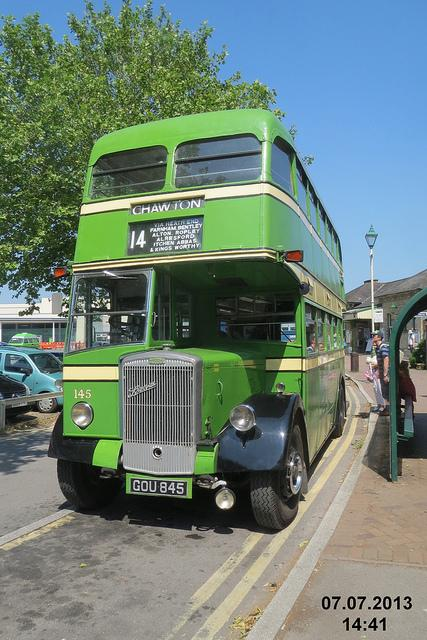In which country does this bus travel? Please explain your reasoning. great britain. The display on the front of the bus says chawton. chawton in a village in hampshire, england. 